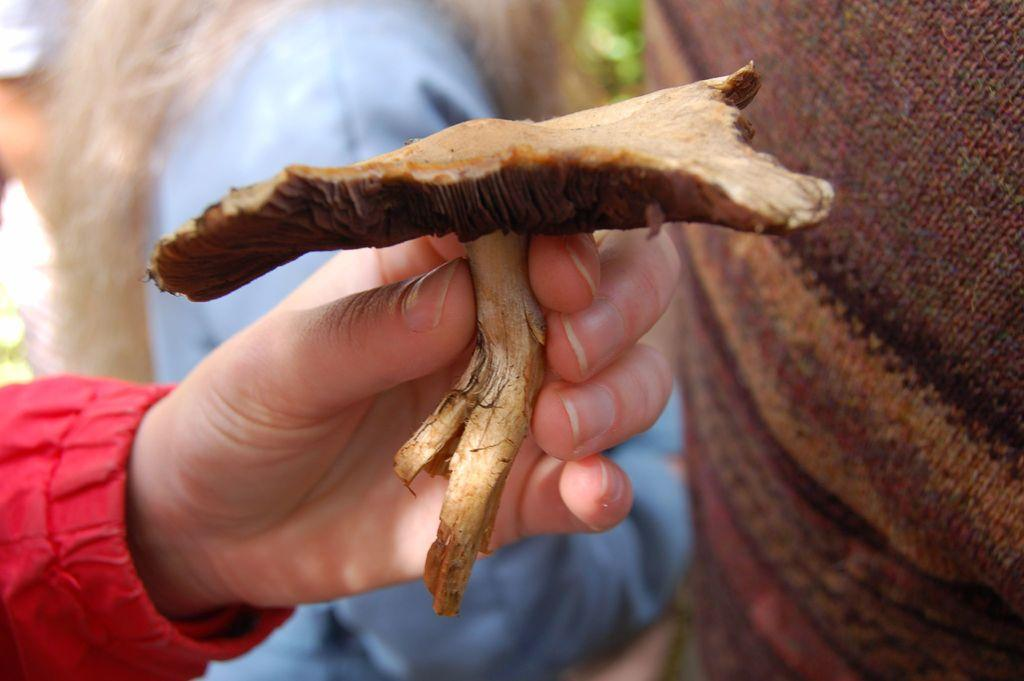What is the human hand holding in the image? The human hand is holding an object in the image. Can you describe the background of the image? The background of the image is blurred. What else can be seen in the image besides the hand and the object it's holding? Clothes are visible in the image. What else is present in the image that is related to a person? Human hair is present in the image. What type of tin can be seen on the chair in the image? There is no chair or tin present in the image. What color is the chalk used to draw on the wall in the image? There is no chalk or drawing on the wall in the image. 